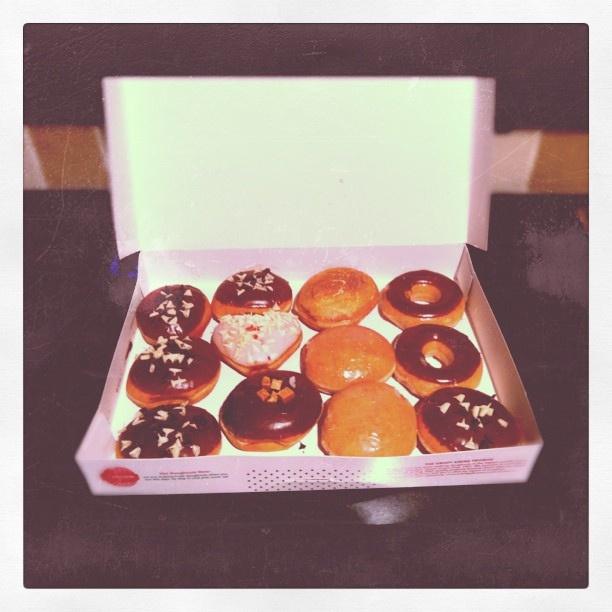Describe the objects in this image and their specific colors. I can see dining table in whitesmoke, beige, and brown tones, donut in whitesmoke and brown tones, donut in whitesmoke, orange, and salmon tones, donut in whitesmoke, brown, and salmon tones, and donut in whitesmoke, brown, salmon, and orange tones in this image. 